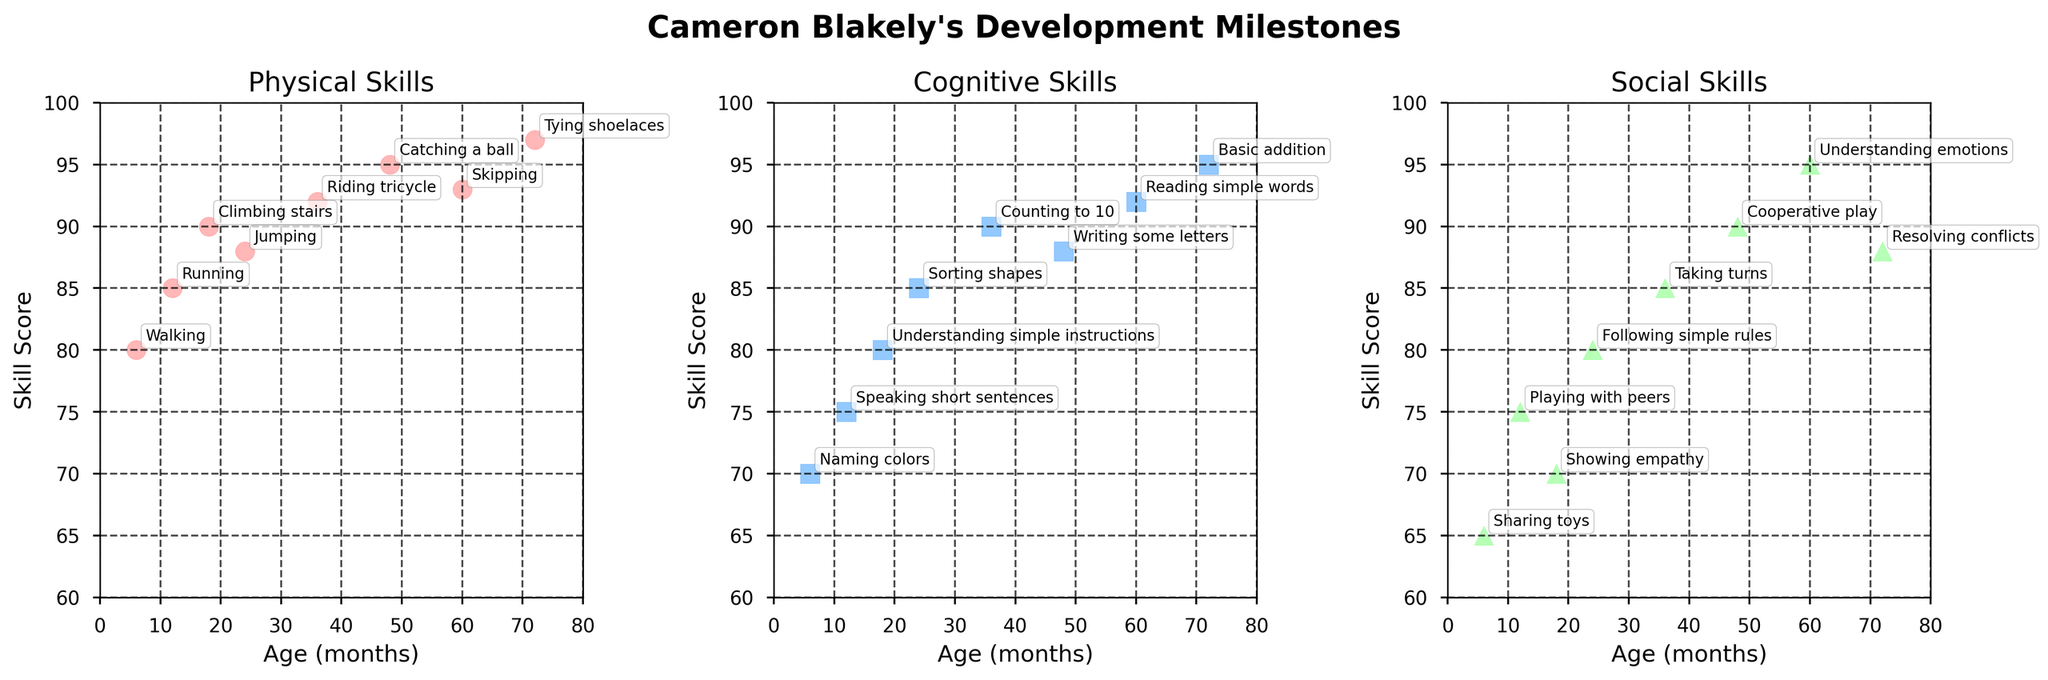How many data points are there for Physical Skills? Count the number of scatter points in the Physical Skills plot.
Answer: 8 Which skill has the highest score in the Cognitive Skills subplot? Observe the Cognitive Skills subplot and identify the skill with the highest y-value.
Answer: Basic addition What is the title of the figure? Read the title at the top of the figure.
Answer: Cameron Blakely's Development Milestones At what age does 'Tying shoelaces' occur, and what is its score? Locate 'Tying shoelaces' in the annotated data points of the Physical Skills subplot and read off the corresponding age and score.
Answer: 72 months, 97 Compare the scores for 'Counting to 10' and 'Writing some letters' in the Cognitive Skills subplot. Which one is higher? Identify and compare the scatter points for 'Counting to 10' and 'Writing some letters' in the Cognitive Skills subplot.
Answer: Counting to 10 Which Social Skill corresponds to the age of 24 months and what is the score? Locate the scatter point in the Social Skills subplot for age 24 months and read the corresponding skill and score.
Answer: Following simple rules, 80 Calculate the average score for Physical Skills. Add all the Physical Scores and divide by the number of data points: (80 + 85 + 90 + 88 + 92 + 95 + 93 + 97) / 8
Answer: 90 At what age does the score for 'Reading simple words' occur and what is the score difference between 'Reading simple words' and 'Speaking short sentences'? Locate 'Reading simple words' in the Cognitive Skills subplot to find its age and score, then compare it to 'Speaking short sentences' and calculate the difference.
Answer: 60 months, 17 What is the relationship between age and skill score across all three subplots? Compare the general trend in all three subplots by observing how the scores change with age.
Answer: Generally increasing Which age group has the highest average score in Social Skills? Identify the scores in the Social Skills subplot, group them by age, and calculate the average for each group.
Answer: 60 months 